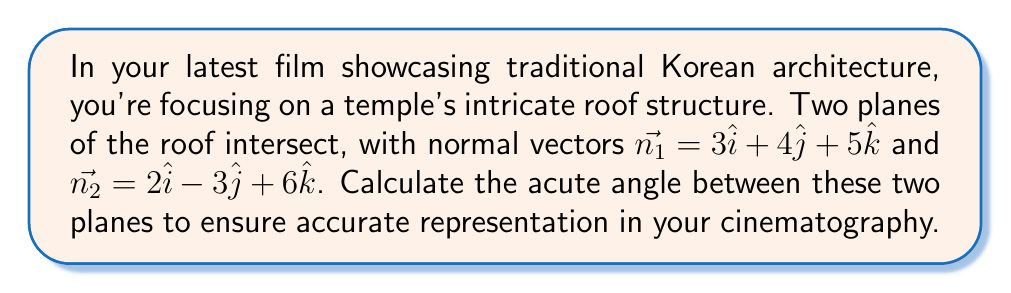Can you answer this question? To find the angle between two intersecting planes, we can use the dot product of their normal vectors. The formula is:

$$\cos \theta = \frac{|\vec{n_1} \cdot \vec{n_2}|}{|\vec{n_1}| |\vec{n_2}|}$$

Where $\theta$ is the angle between the planes.

Step 1: Calculate the dot product $\vec{n_1} \cdot \vec{n_2}$
$$\vec{n_1} \cdot \vec{n_2} = (3)(2) + (4)(-3) + (5)(6) = 6 - 12 + 30 = 24$$

Step 2: Calculate the magnitudes of $\vec{n_1}$ and $\vec{n_2}$
$$|\vec{n_1}| = \sqrt{3^2 + 4^2 + 5^2} = \sqrt{9 + 16 + 25} = \sqrt{50}$$
$$|\vec{n_2}| = \sqrt{2^2 + (-3)^2 + 6^2} = \sqrt{4 + 9 + 36} = \sqrt{49} = 7$$

Step 3: Apply the formula
$$\cos \theta = \frac{|24|}{\sqrt{50} \cdot 7} = \frac{24}{\sqrt{2450}}$$

Step 4: Take the inverse cosine (arccos) to find $\theta$
$$\theta = \arccos(\frac{24}{\sqrt{2450}}) \approx 0.8589 \text{ radians}$$

Step 5: Convert to degrees
$$\theta \approx 0.8589 \cdot \frac{180}{\pi} \approx 49.21°$$
Answer: $49.21°$ 